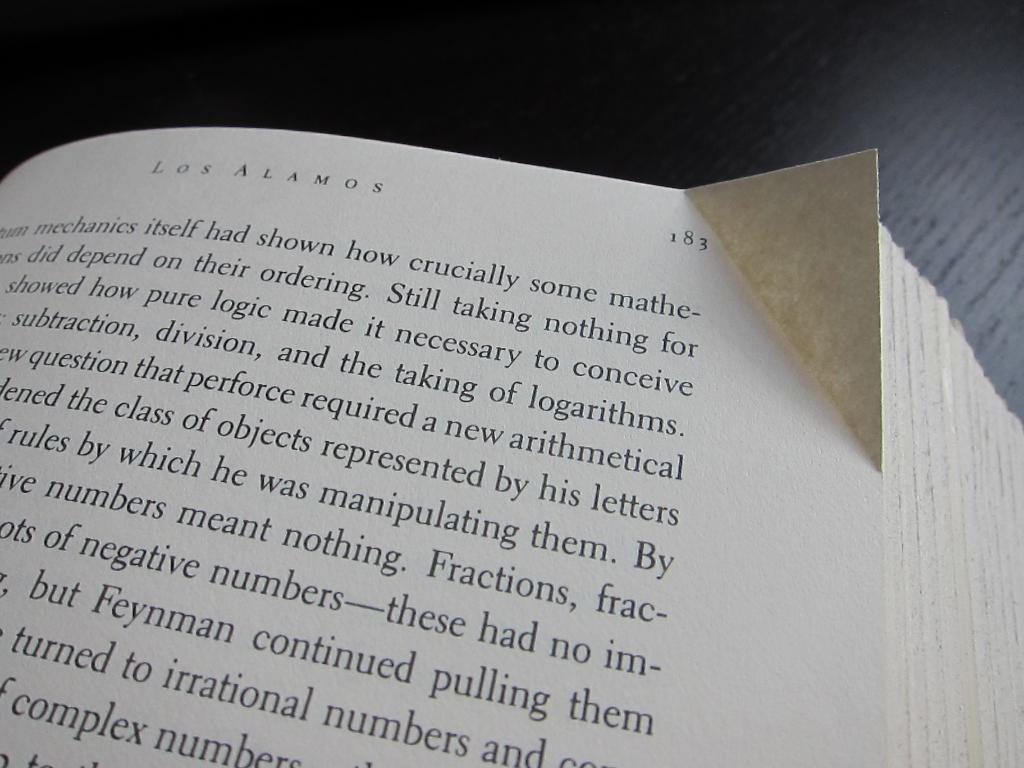Provide a one-sentence caption for the provided image. Book with a creased side on page 183. 